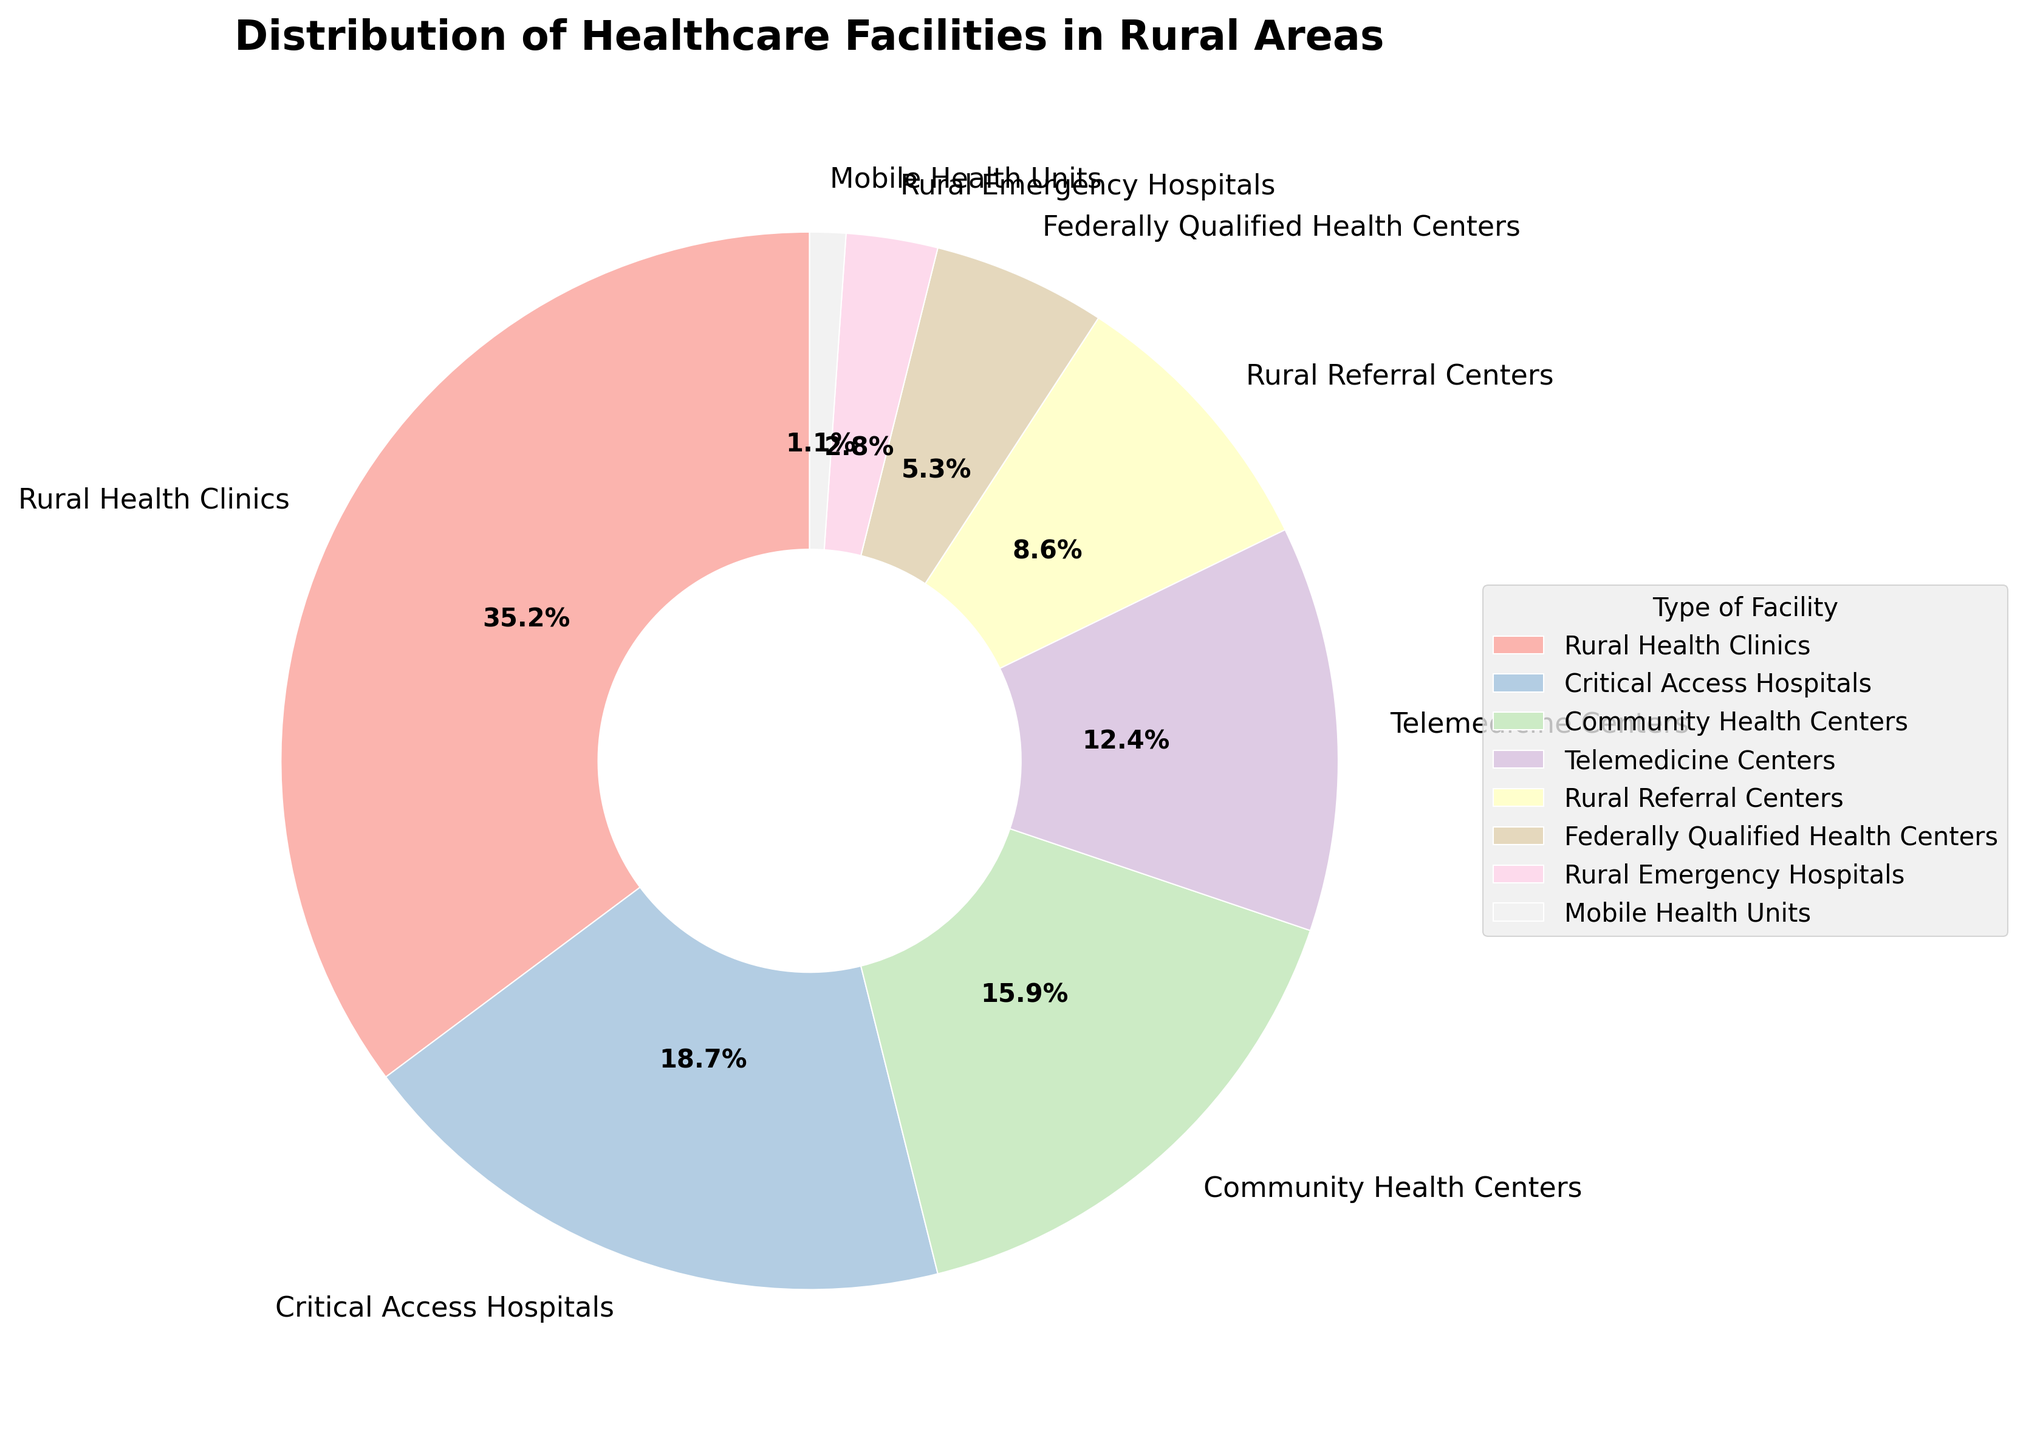What is the percentage share of the two largest types of facilities combined? First, identify the two largest shares from the pie chart, which are "Rural Health Clinics" (35.2%) and "Critical Access Hospitals" (18.7%). Then, sum these percentages: 35.2% + 18.7% = 53.9%.
Answer: 53.9% Which type of facility is less prevalent: Telemedicine Centers or Community Health Centers? Check the percentages of both types on the pie chart. Telemedicine Centers have 12.4% and Community Health Centers have 15.9%. Since 12.4% is less than 15.9%, Telemedicine Centers are less prevalent.
Answer: Telemedicine Centers By how much does the percentage of Rural Health Clinics exceed that of Federally Qualified Health Centers? Identify the percentages from the pie chart: Rural Health Clinics (35.2%) and Federally Qualified Health Centers (5.3%). Compute the difference: 35.2% - 5.3% = 29.9%.
Answer: 29.9% Are Rural Emergency Hospitals or Mobile Health Units the least common type of facility, and what are their respective percentages? Check the percentages from the pie chart: Rural Emergency Hospitals have 2.8% and Mobile Health Units have 1.1%. Since 1.1% is less than 2.8%, Mobile Health Units are the least common. Their percentages are 1.1% and 2.8%, respectively.
Answer: Mobile Health Units; 1.1% and 2.8% What is the average percentage share of Community Health Centers, Rural Referral Centers, and Telemedicine Centers combined? First, find their individual percentages: Community Health Centers (15.9%), Rural Referral Centers (8.6%), Telemedicine Centers (12.4%). Then, sum these percentages: 15.9% + 8.6% + 12.4% = 36.9%. Finally, divide by the number of facilities (3): 36.9% / 3 = 12.3%.
Answer: 12.3% Which facility type has a visual slice closest in size to the slice for Rural Referral Centers? Find the percentage of Rural Referral Centers, which is 8.6%. Compare it with others to find the closest value, which is Federally Qualified Health Centers at 5.3%. Since 8.6% and 5.3% are not very close, check with Rural Emergency Hospitals at 2.8%. The closest percentage is still Federally Qualified Health Centers.
Answer: Federally Qualified Health Centers If Community Health Centers increased their share by 5%, what would their new percentage be, and would they then surpass Critical Access Hospitals in size? First, calculate the new percentage: 15.9% + 5% = 20.9%. Next, compare 20.9% with Critical Access Hospitals' 18.7%. Since 20.9% > 18.7%, yes, they would surpass Critical Access Hospitals.
Answer: 20.9%; Yes What is the total percentage of all facility types other than Rural Health Clinics? Subtract the percentage of Rural Health Clinics from 100%: 100% - 35.2% = 64.8%.
Answer: 64.8% Which type of facility shares similar visual characteristics, such as color, with the Rural Referral Centers in the pie chart? Since the pie chart uses a color scheme from Pastel1 and colors can be similar in that palette, identify the color segments and compare them visually. Notice the colors for Rural Referral Centers and the adjacent slice.
Answer: Check visually in the rendered pie chart (specific color comparison might vary) 